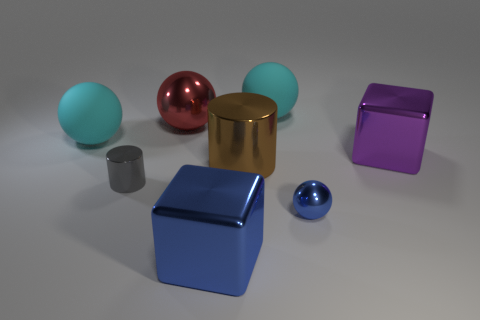How many shiny objects are the same color as the small metallic ball? Upon close examination of the image, it appears there is one other object—a larger ball—that shares the same rich blue hue as the small metallic ball. Both exhibit a reflective surface, hinting at their metallic nature. 